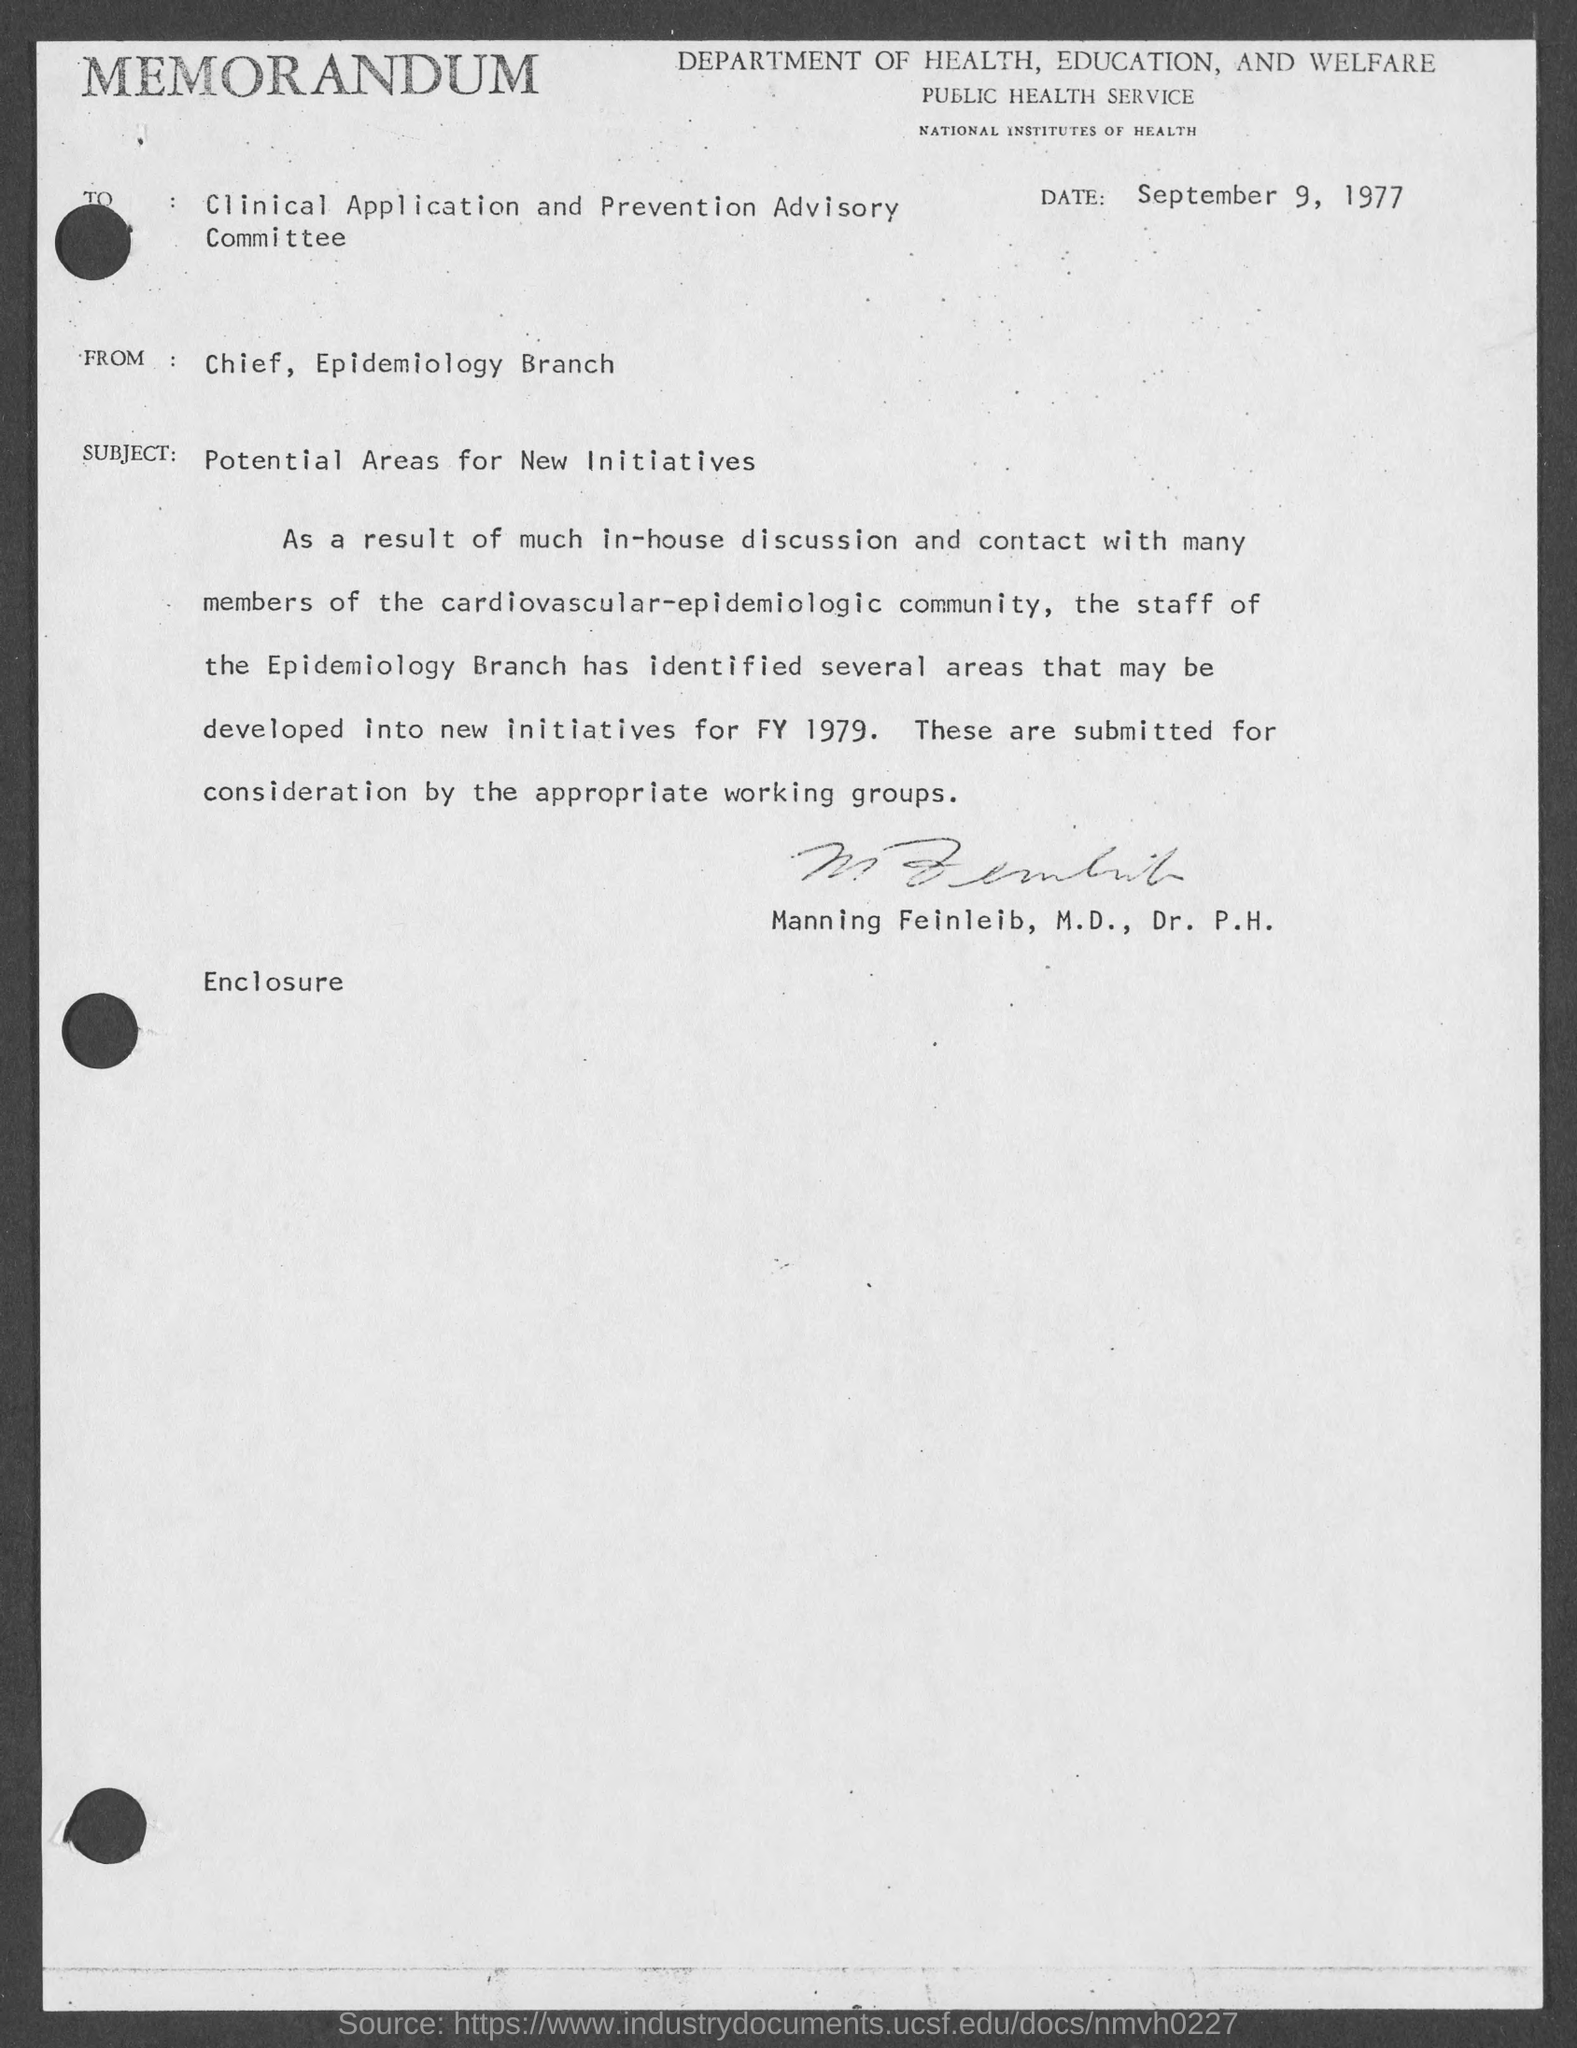When is the memorandum dated?
Provide a succinct answer. September 9, 1977. What is the from address in memorandum ?
Your answer should be very brief. Chief, Epidemiology Branch. What is the subject of memorandum ?
Ensure brevity in your answer.  Potential Areas for New Initiatives. 